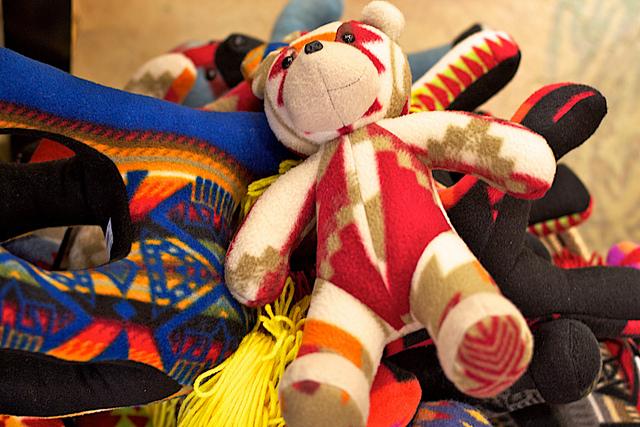Are these stuffed animals?
Write a very short answer. Yes. How many toys are visible?
Keep it brief. 5. Is this teddy bear cool?
Short answer required. Yes. 